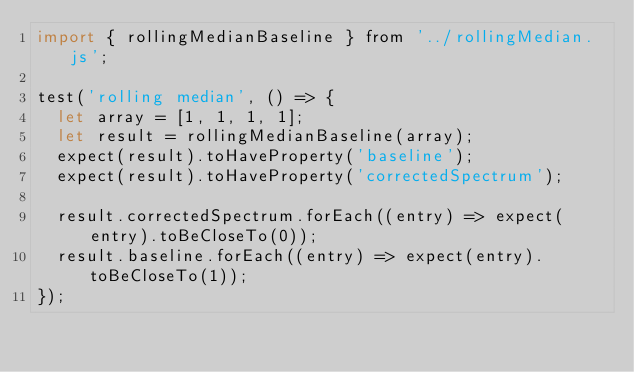<code> <loc_0><loc_0><loc_500><loc_500><_JavaScript_>import { rollingMedianBaseline } from '../rollingMedian.js';

test('rolling median', () => {
  let array = [1, 1, 1, 1];
  let result = rollingMedianBaseline(array);
  expect(result).toHaveProperty('baseline');
  expect(result).toHaveProperty('correctedSpectrum');

  result.correctedSpectrum.forEach((entry) => expect(entry).toBeCloseTo(0));
  result.baseline.forEach((entry) => expect(entry).toBeCloseTo(1));
});
</code> 